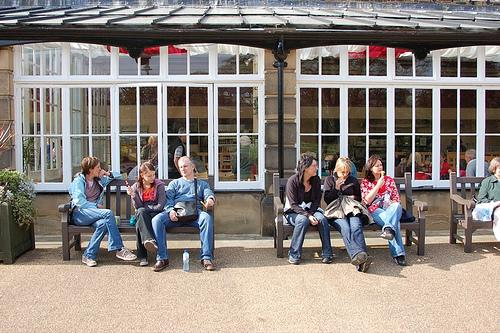Describe the appearance of the bench and its surroundings. The bench is wooden with legs and an arm, placed near a pole, planter, and a water bottle on the ground. Describe the appearance and positioning of the water bottle in the image. The water bottle is on the ground between a man's feet, with a blue cap, located under the bench. Mention the objects found near the sitting area. A water bottle, a plastic bag, a pole, a planter with plants, and a black leather bag are nearby the sitting area. Explain the scene inside the building visible through the windows. People are visible inside the building through white-framed windows that occupy most of the wall space. Describe the seating arrangement of the individuals in the image. Two women sit on a bench between other women, a man and woman sit close, and a person seats at the corner of a bench. Provide a brief description of the main activity taking place. Several people sitting on benches outside a building, some with their legs crossed, a woman eating ice cream, and a water bottle on the ground. What attire are the main individuals in the image wearing? A woman wears blue jeans, another with a red shirt, a man has a black bag in his lap, and a girl with a grey sweatshirt. Write a sentence about the scene's environment and objects, incorporating the people in the image. People sit on brown wooden benches near a brown ground, water bottle, and green planter amidst white-framed windows. List the types of clothing and accessories worn by the people in the picture. Blue jeans, brown jackets, black bag, black band, red and white top, blue jacket, and grey sweatshirt. What is the position of the woman eating ice cream with respect to the other people? The woman eating ice cream is sitting between two other women on a bench. 